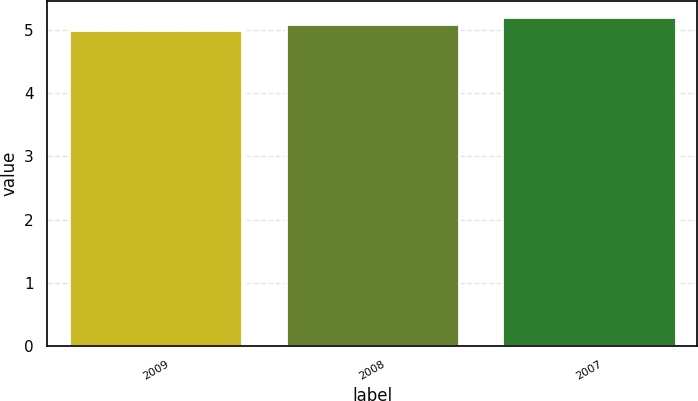<chart> <loc_0><loc_0><loc_500><loc_500><bar_chart><fcel>2009<fcel>2008<fcel>2007<nl><fcel>5<fcel>5.1<fcel>5.2<nl></chart> 